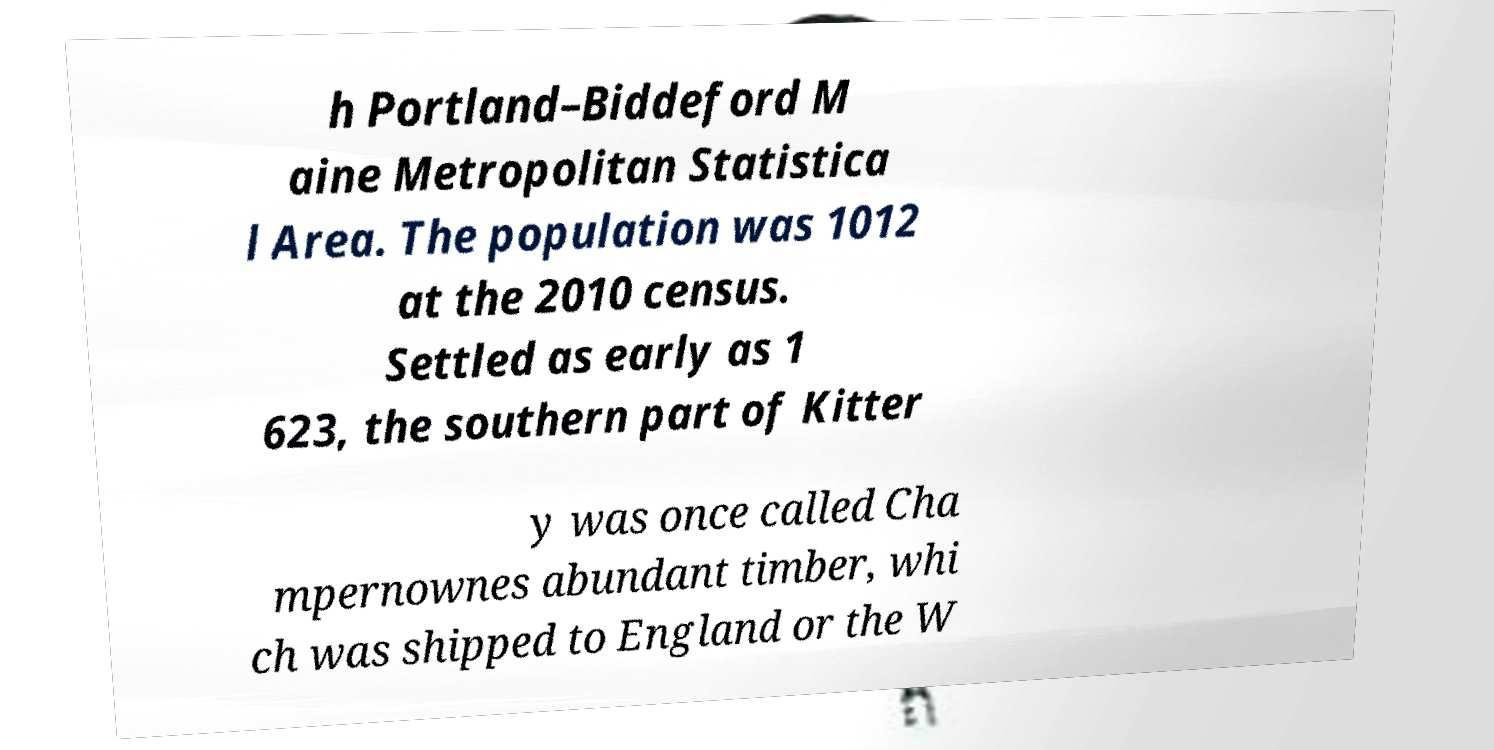For documentation purposes, I need the text within this image transcribed. Could you provide that? h Portland–Biddeford M aine Metropolitan Statistica l Area. The population was 1012 at the 2010 census. Settled as early as 1 623, the southern part of Kitter y was once called Cha mpernownes abundant timber, whi ch was shipped to England or the W 